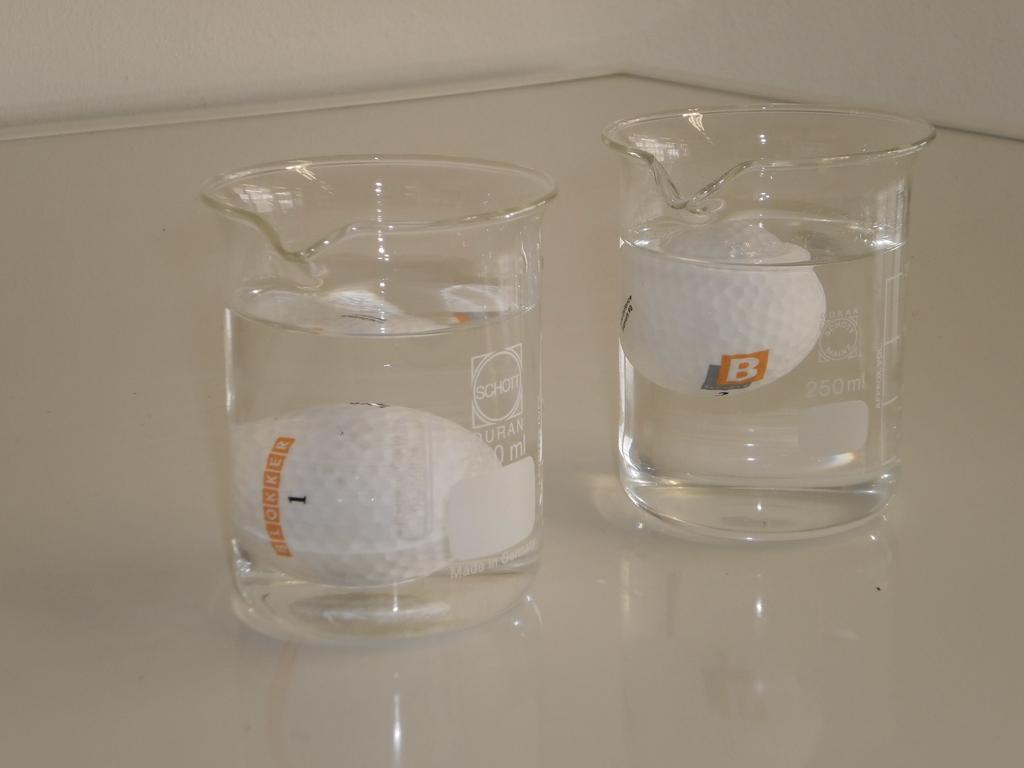<image>
Render a clear and concise summary of the photo. two golf balls with B on them in clear  Schott beakers 